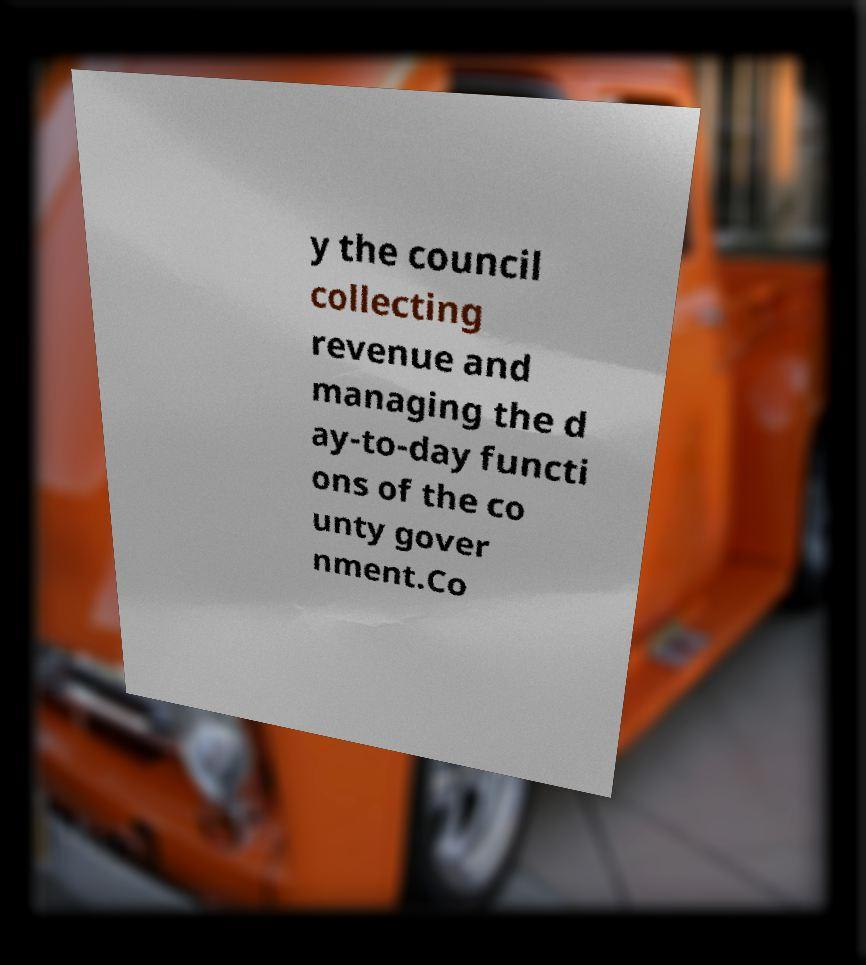I need the written content from this picture converted into text. Can you do that? y the council collecting revenue and managing the d ay-to-day functi ons of the co unty gover nment.Co 